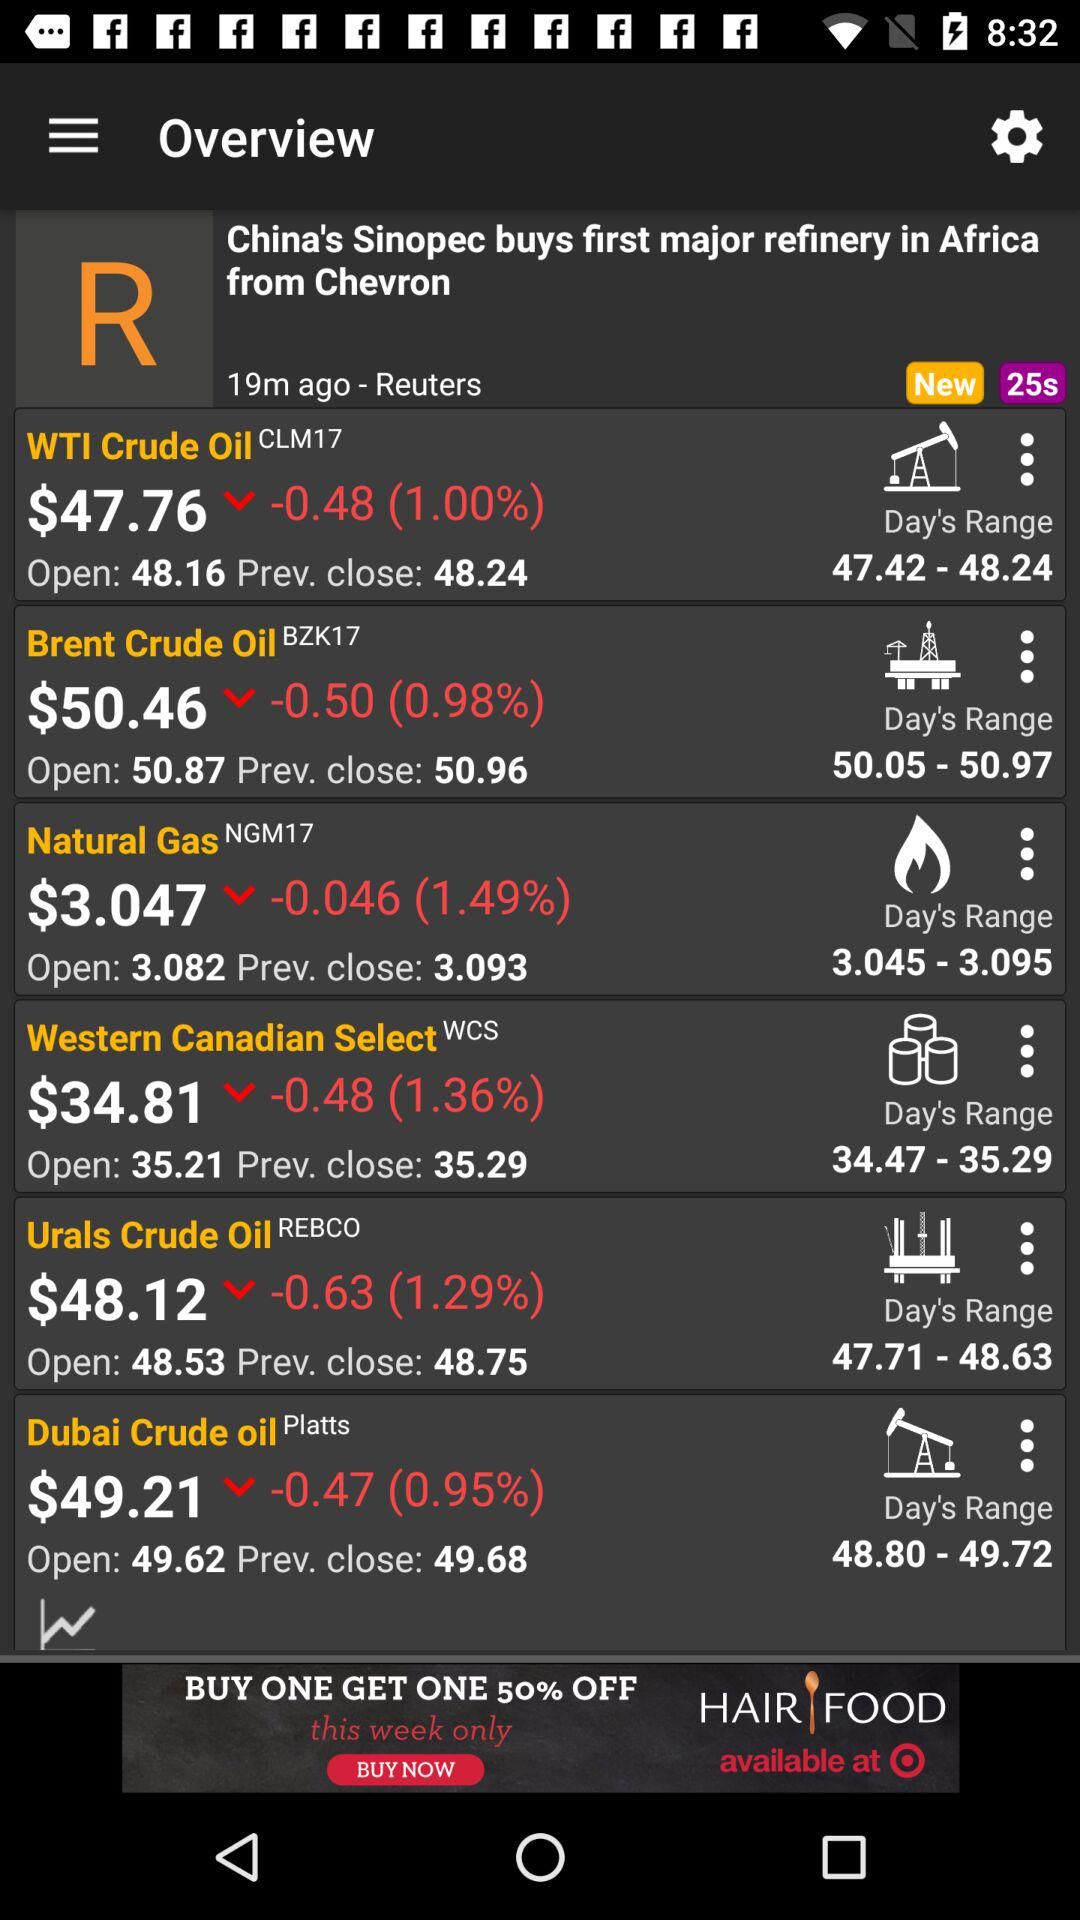What is the stock price of "Natural Gas"? The stock price is $3.047. 